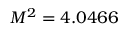Convert formula to latex. <formula><loc_0><loc_0><loc_500><loc_500>M ^ { 2 } = 4 . 0 4 6 6</formula> 